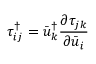Convert formula to latex. <formula><loc_0><loc_0><loc_500><loc_500>\tau _ { i j } ^ { \dag } = \bar { u } _ { k } ^ { \dag } \frac { { \partial { \tau _ { j k } } } } { { \partial { { \bar { u } } _ { i } } } }</formula> 